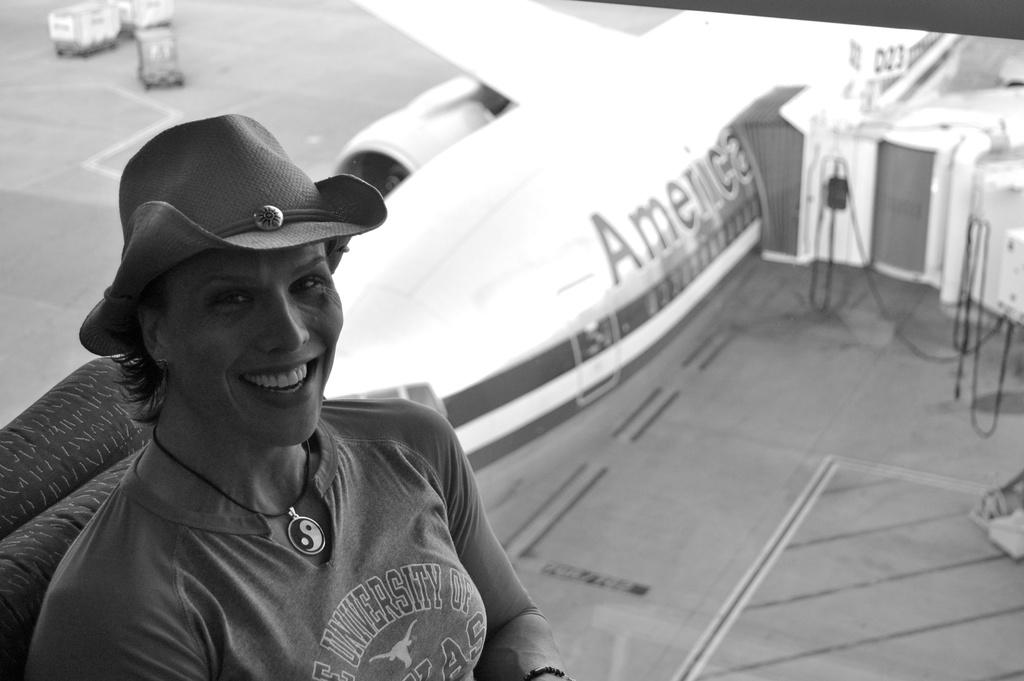What is the color scheme of the image? The image is black and white. Who is the main subject in the foreground of the image? There is a lady wearing a hat in the foreground of the image. What can be seen in the background of the image? There is an aeroplane in the background of the image. What type of vehicles are present in the image? There are trucks in the image. What type of mitten is the lady wearing in the image? The lady is not wearing a mitten in the image; she is wearing a hat. How does friction affect the movement of the aeroplane in the image? There is no information about the movement of the aeroplane in the image, nor is there any information about friction. 